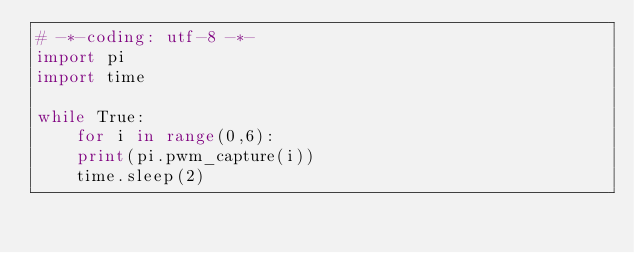<code> <loc_0><loc_0><loc_500><loc_500><_Python_># -*-coding: utf-8 -*-
import pi
import time

while True:
    for i in range(0,6):
	print(pi.pwm_capture(i))
    time.sleep(2)
</code> 